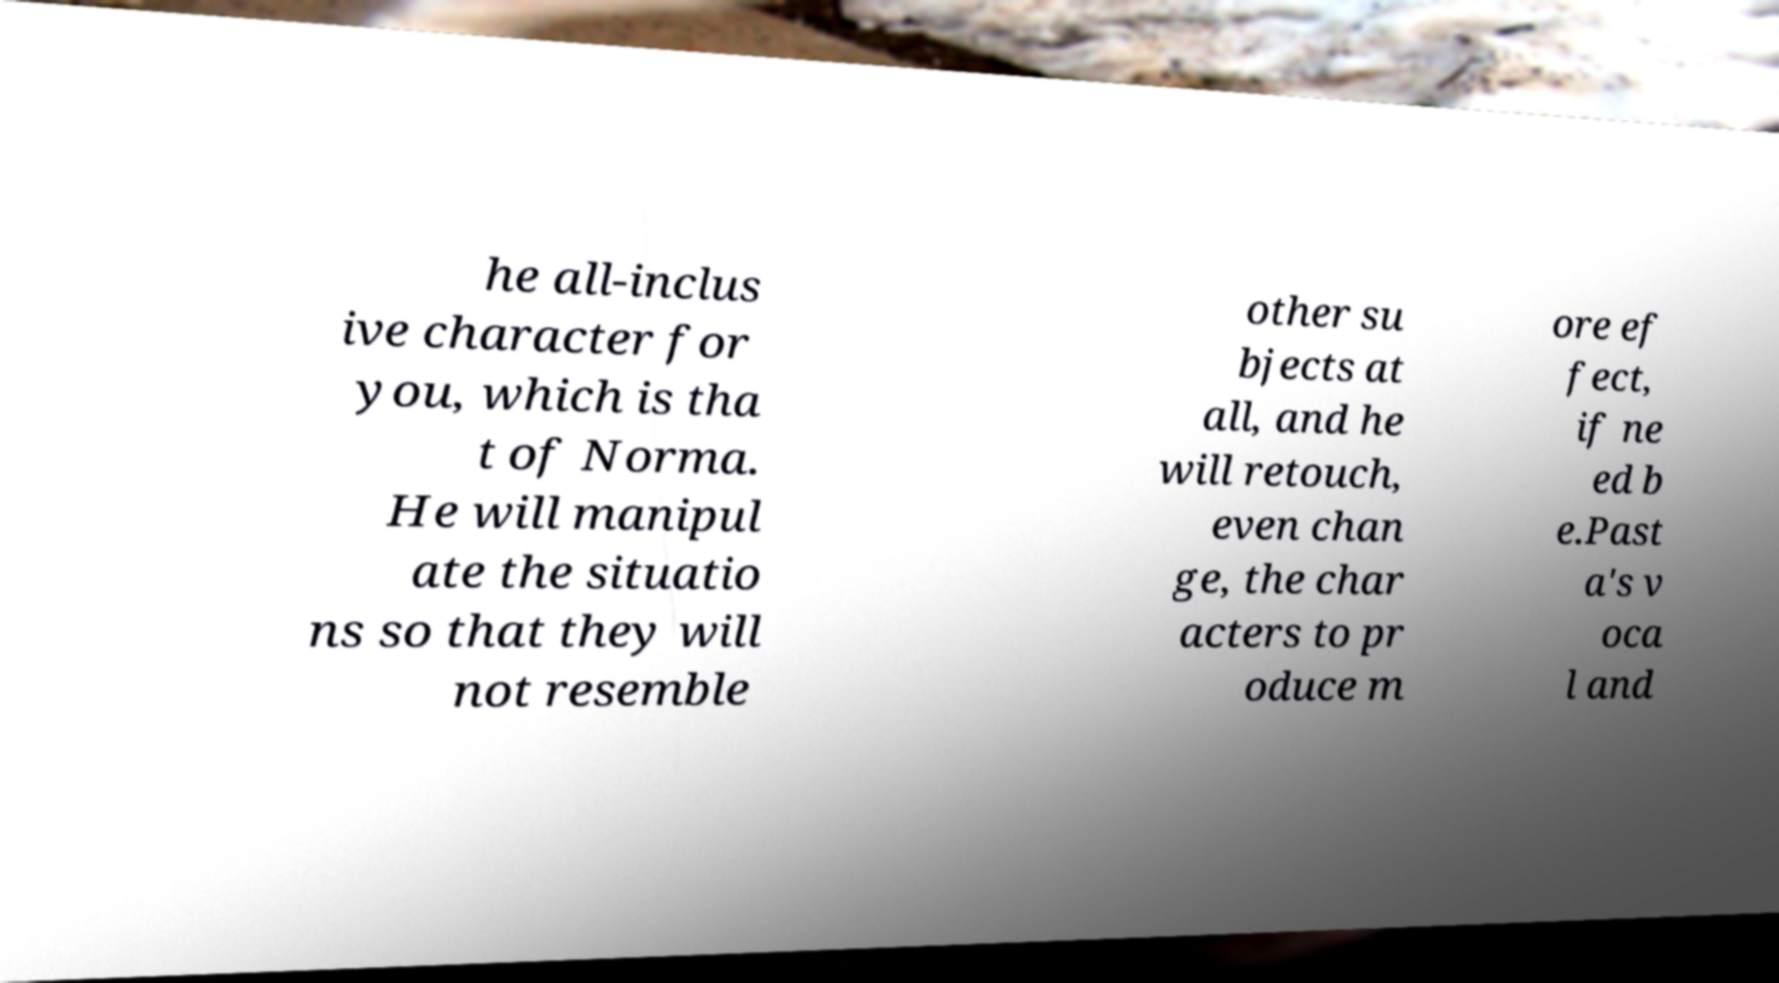Can you accurately transcribe the text from the provided image for me? he all-inclus ive character for you, which is tha t of Norma. He will manipul ate the situatio ns so that they will not resemble other su bjects at all, and he will retouch, even chan ge, the char acters to pr oduce m ore ef fect, if ne ed b e.Past a's v oca l and 